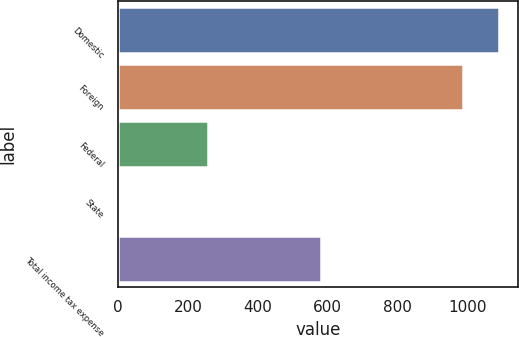Convert chart to OTSL. <chart><loc_0><loc_0><loc_500><loc_500><bar_chart><fcel>Domestic<fcel>Foreign<fcel>Federal<fcel>State<fcel>Total income tax expense<nl><fcel>1089.8<fcel>986<fcel>258<fcel>5<fcel>580<nl></chart> 